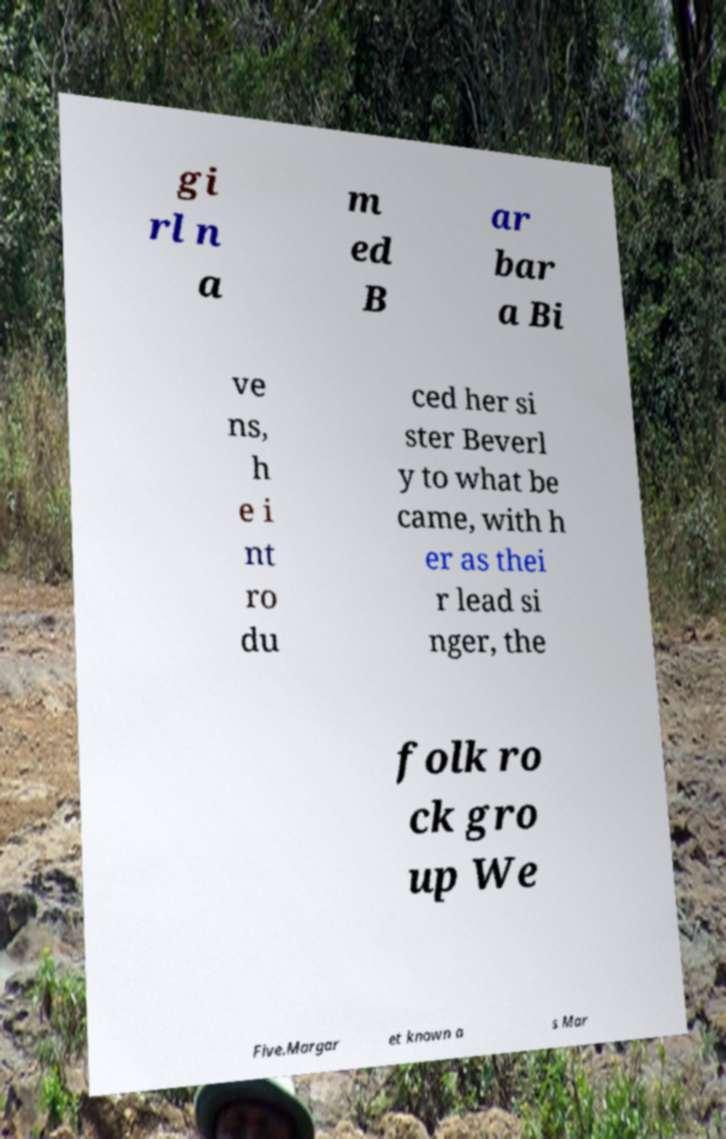Can you read and provide the text displayed in the image?This photo seems to have some interesting text. Can you extract and type it out for me? gi rl n a m ed B ar bar a Bi ve ns, h e i nt ro du ced her si ster Beverl y to what be came, with h er as thei r lead si nger, the folk ro ck gro up We Five.Margar et known a s Mar 